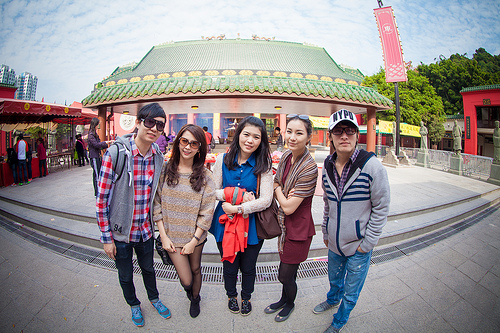<image>
Can you confirm if the shoes is under the girl? No. The shoes is not positioned under the girl. The vertical relationship between these objects is different. Where is the woman in relation to the man? Is it behind the man? No. The woman is not behind the man. From this viewpoint, the woman appears to be positioned elsewhere in the scene. Where is the man in relation to the building? Is it next to the building? No. The man is not positioned next to the building. They are located in different areas of the scene. 